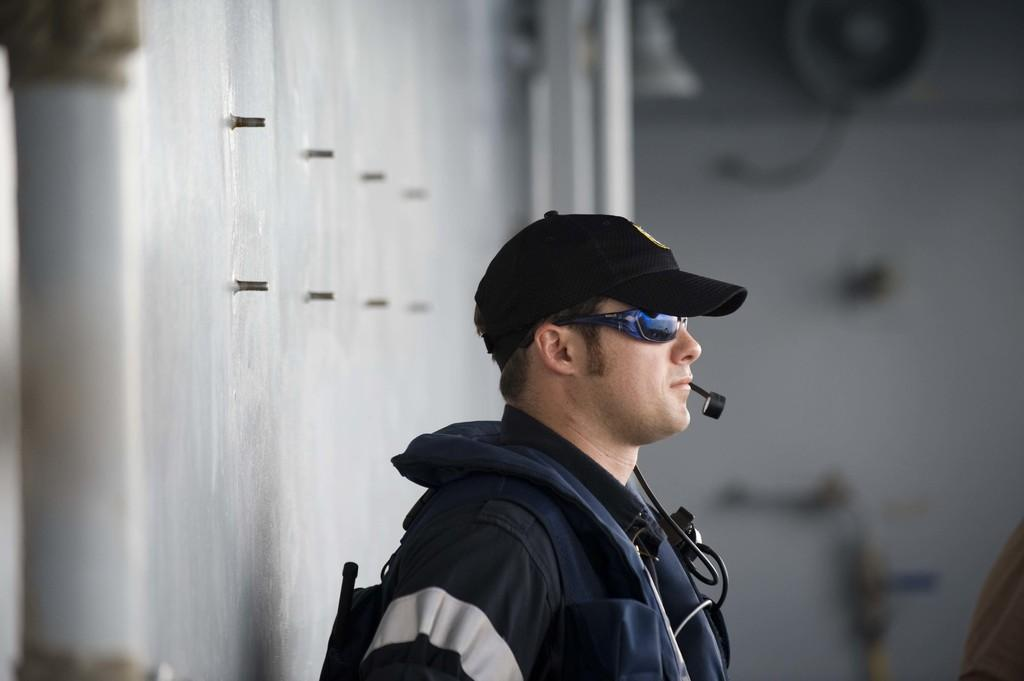What is the main subject of the image? There is a man standing in the image. What is the man holding or wearing in the image? The man has a microphone attached to him. What can be seen in the background of the image? There is a wall in the background of the image. What type of jeans is the man wearing in the image? There is no information about the man's jeans in the image, so we cannot determine the type of jeans he is wearing. 